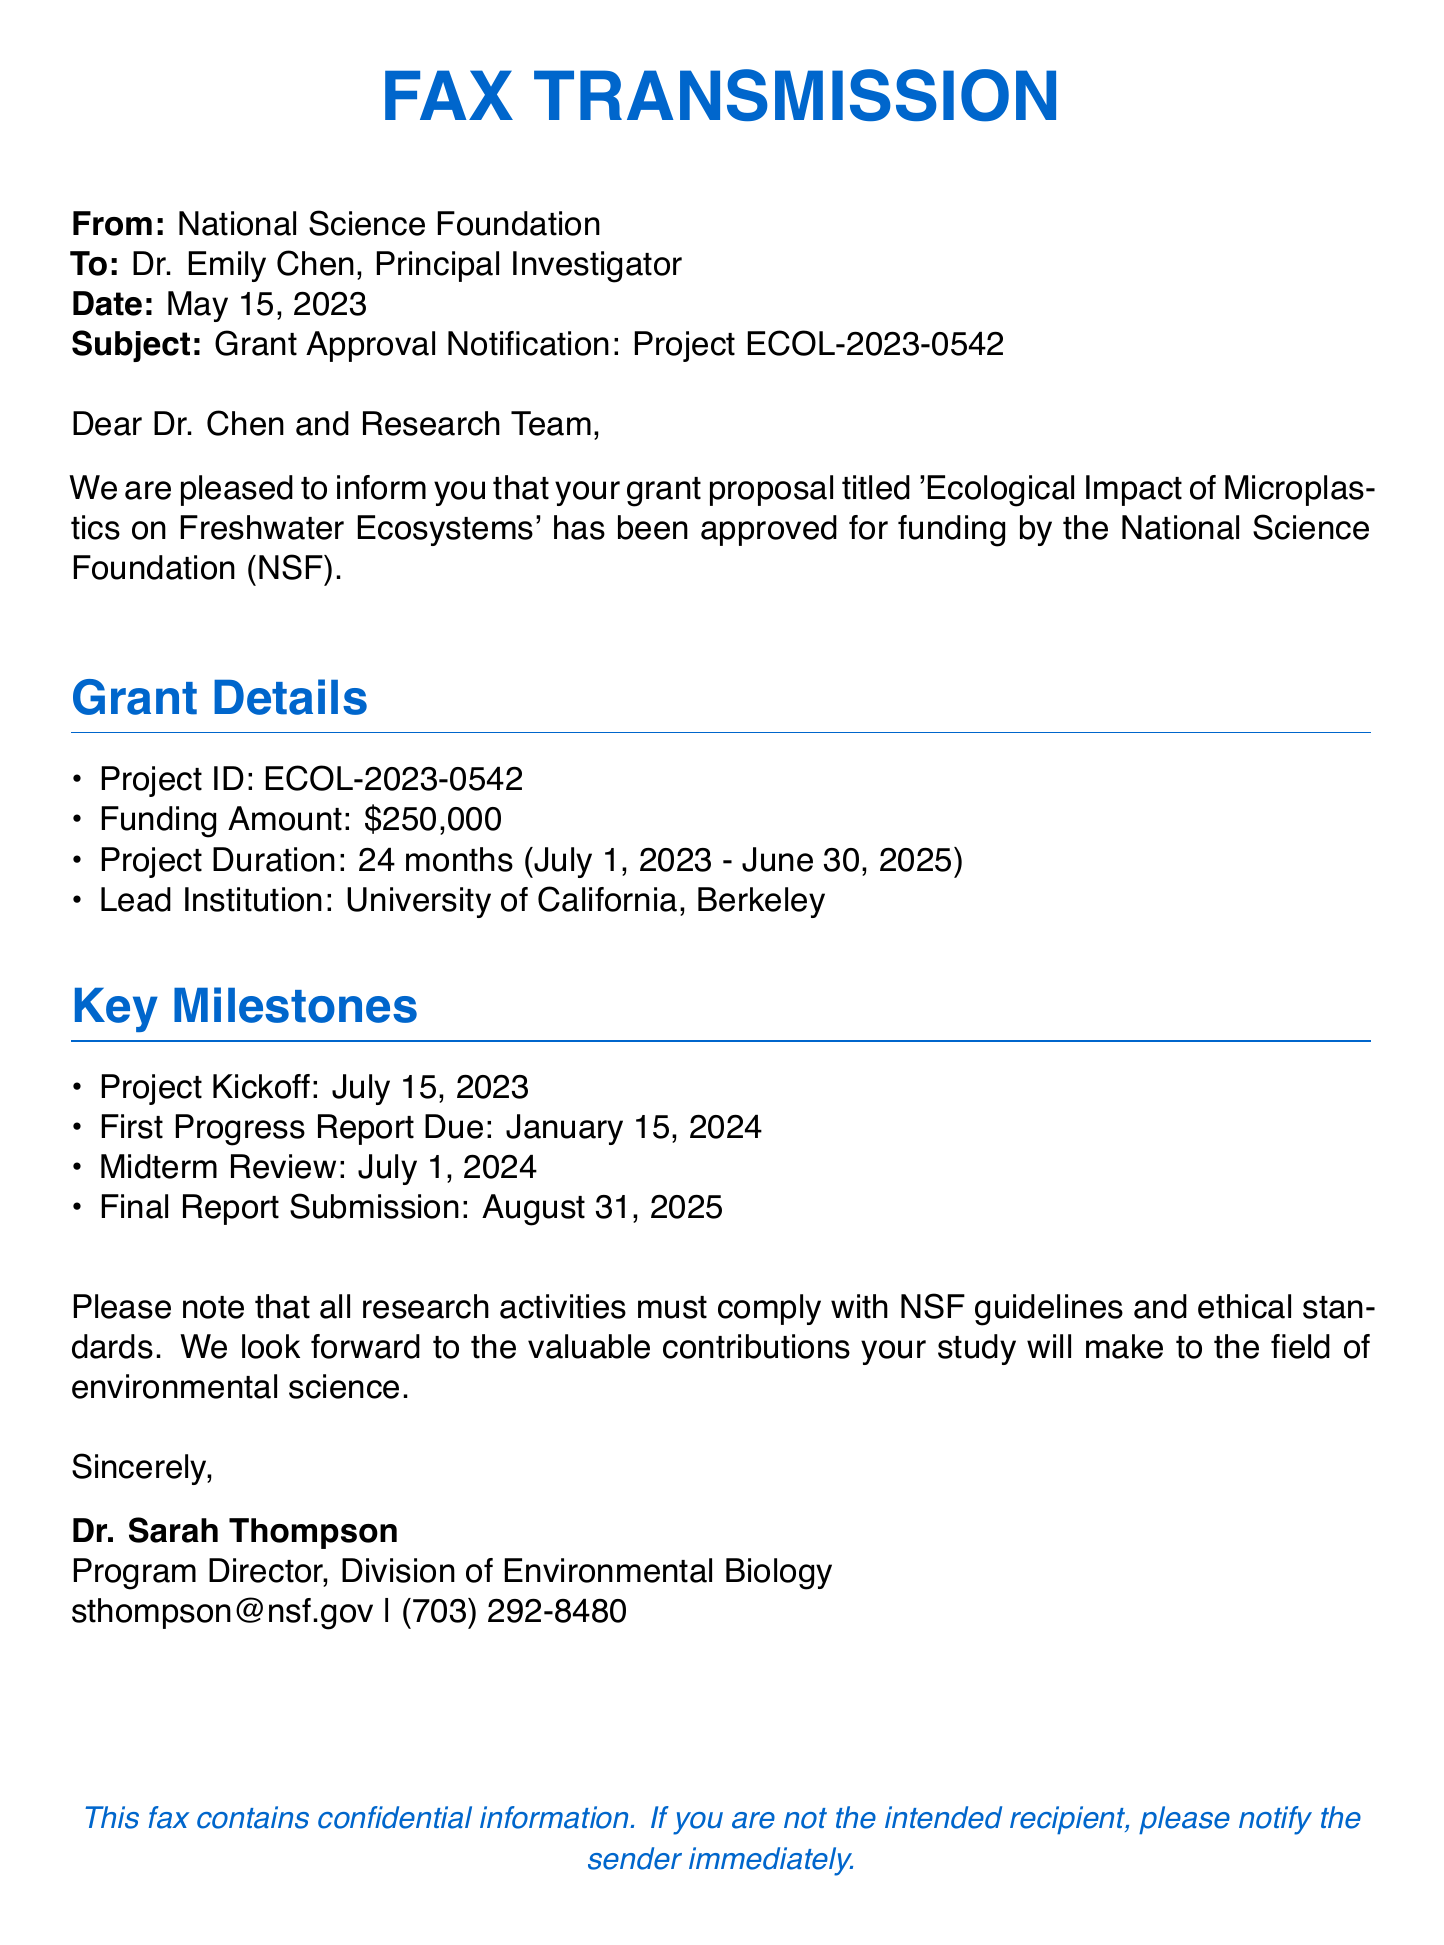What is the project title? The project title is mentioned in the letter, which is 'Ecological Impact of Microplastics on Freshwater Ecosystems'.
Answer: Ecological Impact of Microplastics on Freshwater Ecosystems What is the funding amount? The funding amount is specified in the grant details section.
Answer: $250,000 What is the project duration? The project duration is listed in the grant details section as 24 months from July 1, 2023, to June 30, 2025.
Answer: 24 months Who is the Program Director? The Program Director's name is provided at the end of the fax.
Answer: Dr. Sarah Thompson When is the first progress report due? The due date for the first progress report is stated in the key milestones section.
Answer: January 15, 2024 What is the Project ID? The Project ID is mentioned in the grant details section.
Answer: ECOL-2023-0542 How many key milestones are listed? The number of key milestones can be counted from the key milestones section in the document.
Answer: 4 What institution is the lead for the project? The lead institution is specified in the grant details section.
Answer: University of California, Berkeley What must research activities comply with? The compliance requirement is noted at the end of the letter.
Answer: NSF guidelines and ethical standards 